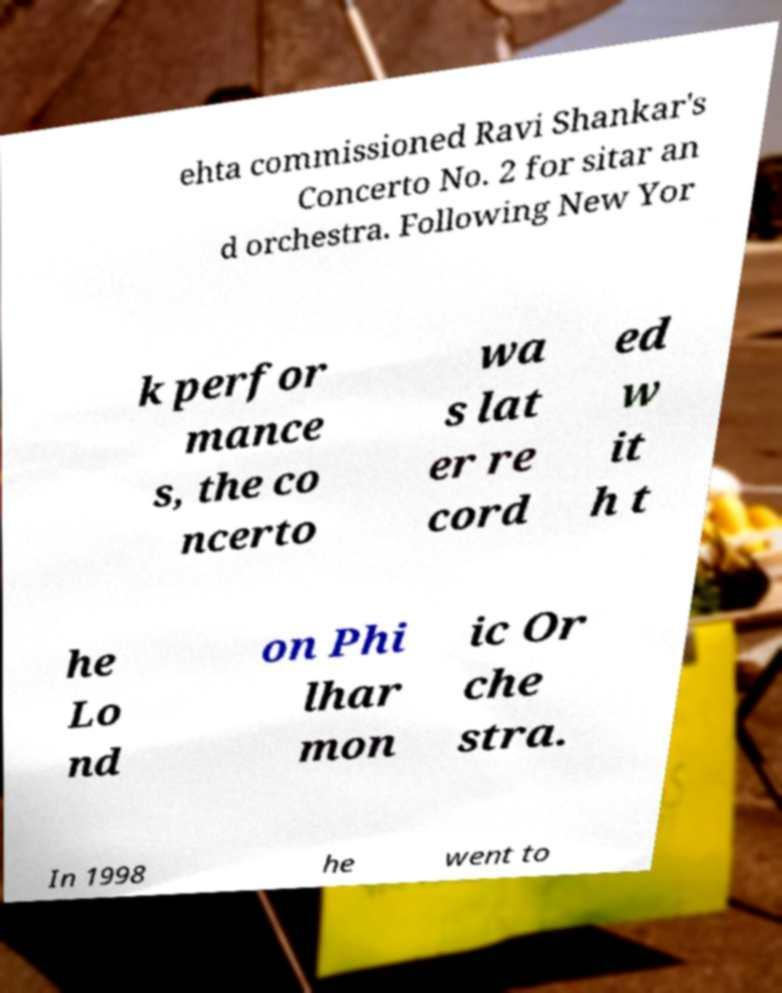I need the written content from this picture converted into text. Can you do that? ehta commissioned Ravi Shankar's Concerto No. 2 for sitar an d orchestra. Following New Yor k perfor mance s, the co ncerto wa s lat er re cord ed w it h t he Lo nd on Phi lhar mon ic Or che stra. In 1998 he went to 